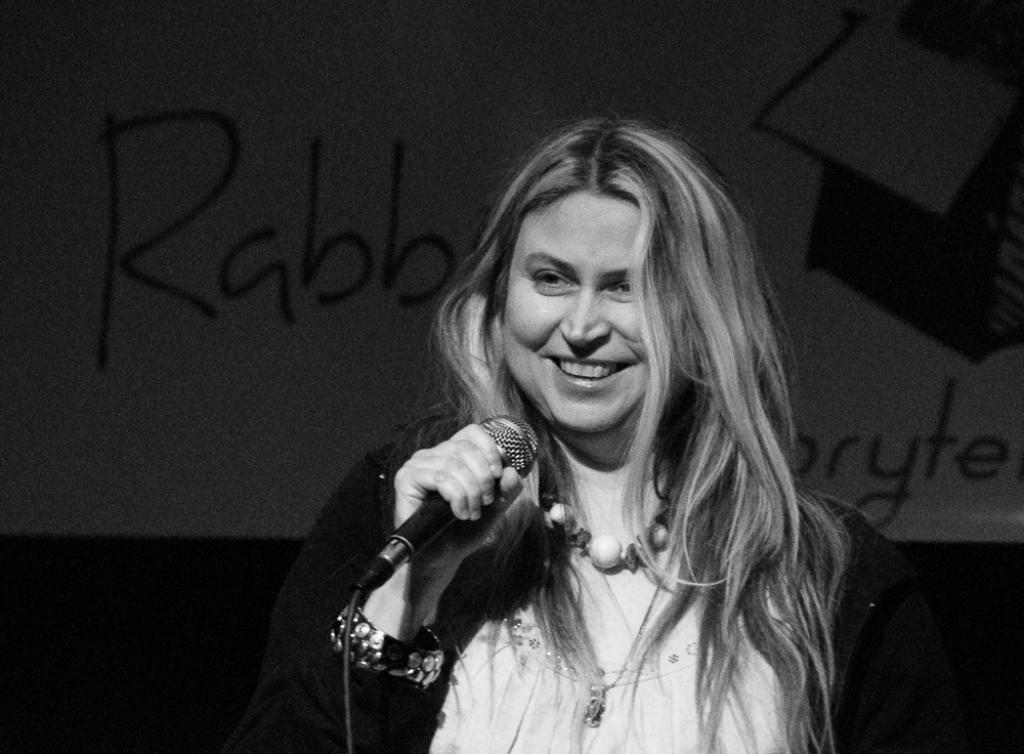Could you give a brief overview of what you see in this image? This is a black and white image. In the center of the image there is a lady holding a mic in her hand. In the background of the image there is a poster. 